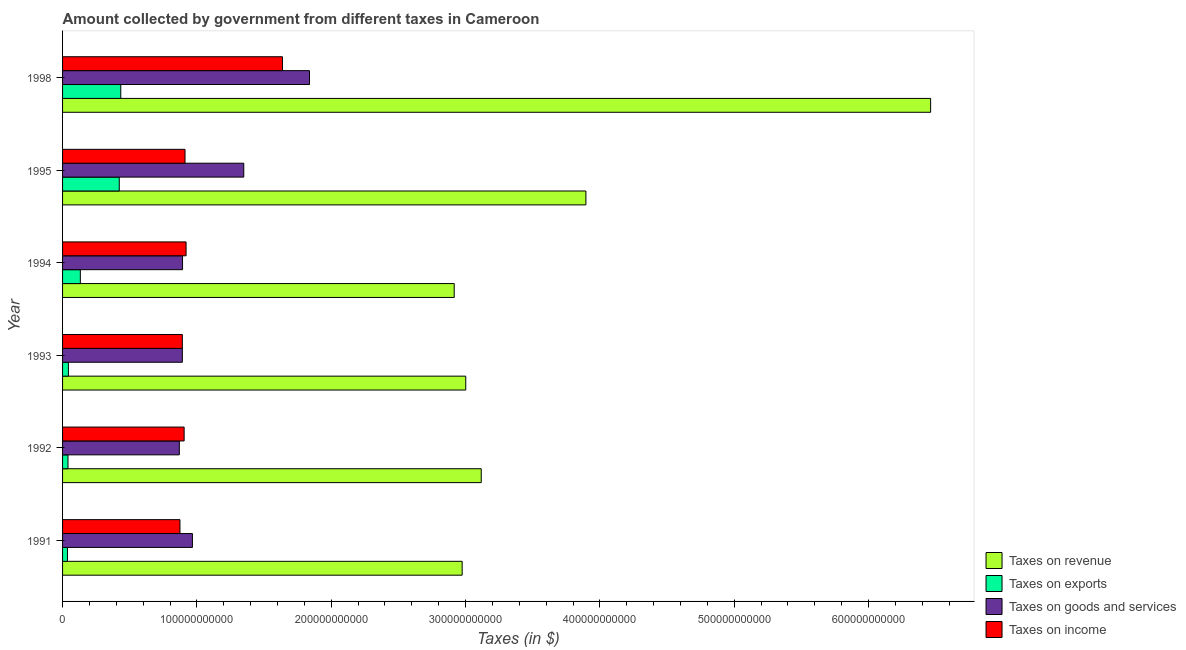How many different coloured bars are there?
Provide a short and direct response. 4. How many bars are there on the 2nd tick from the top?
Ensure brevity in your answer.  4. How many bars are there on the 6th tick from the bottom?
Offer a very short reply. 4. What is the label of the 3rd group of bars from the top?
Your answer should be compact. 1994. In how many cases, is the number of bars for a given year not equal to the number of legend labels?
Keep it short and to the point. 0. What is the amount collected as tax on exports in 1995?
Make the answer very short. 4.22e+1. Across all years, what is the maximum amount collected as tax on exports?
Your response must be concise. 4.33e+1. Across all years, what is the minimum amount collected as tax on exports?
Give a very brief answer. 3.64e+09. In which year was the amount collected as tax on exports maximum?
Provide a succinct answer. 1998. What is the total amount collected as tax on income in the graph?
Make the answer very short. 6.14e+11. What is the difference between the amount collected as tax on goods in 1993 and that in 1995?
Provide a short and direct response. -4.57e+1. What is the difference between the amount collected as tax on goods in 1995 and the amount collected as tax on income in 1992?
Your answer should be compact. 4.44e+1. What is the average amount collected as tax on goods per year?
Keep it short and to the point. 1.13e+11. In the year 1991, what is the difference between the amount collected as tax on revenue and amount collected as tax on income?
Your response must be concise. 2.10e+11. What is the ratio of the amount collected as tax on exports in 1992 to that in 1995?
Give a very brief answer. 0.1. Is the difference between the amount collected as tax on revenue in 1993 and 1998 greater than the difference between the amount collected as tax on income in 1993 and 1998?
Provide a short and direct response. No. What is the difference between the highest and the second highest amount collected as tax on revenue?
Ensure brevity in your answer.  2.57e+11. What is the difference between the highest and the lowest amount collected as tax on goods?
Provide a succinct answer. 9.69e+1. Is the sum of the amount collected as tax on revenue in 1991 and 1998 greater than the maximum amount collected as tax on exports across all years?
Ensure brevity in your answer.  Yes. What does the 2nd bar from the top in 1995 represents?
Provide a short and direct response. Taxes on goods and services. What does the 4th bar from the bottom in 1993 represents?
Keep it short and to the point. Taxes on income. Is it the case that in every year, the sum of the amount collected as tax on revenue and amount collected as tax on exports is greater than the amount collected as tax on goods?
Give a very brief answer. Yes. What is the difference between two consecutive major ticks on the X-axis?
Give a very brief answer. 1.00e+11. Does the graph contain any zero values?
Offer a very short reply. No. How many legend labels are there?
Your answer should be very brief. 4. How are the legend labels stacked?
Provide a succinct answer. Vertical. What is the title of the graph?
Provide a succinct answer. Amount collected by government from different taxes in Cameroon. Does "Social Protection" appear as one of the legend labels in the graph?
Your response must be concise. No. What is the label or title of the X-axis?
Keep it short and to the point. Taxes (in $). What is the Taxes (in $) of Taxes on revenue in 1991?
Give a very brief answer. 2.97e+11. What is the Taxes (in $) in Taxes on exports in 1991?
Ensure brevity in your answer.  3.64e+09. What is the Taxes (in $) in Taxes on goods and services in 1991?
Offer a very short reply. 9.67e+1. What is the Taxes (in $) of Taxes on income in 1991?
Your answer should be compact. 8.74e+1. What is the Taxes (in $) of Taxes on revenue in 1992?
Make the answer very short. 3.12e+11. What is the Taxes (in $) of Taxes on exports in 1992?
Provide a short and direct response. 4.03e+09. What is the Taxes (in $) in Taxes on goods and services in 1992?
Provide a short and direct response. 8.69e+1. What is the Taxes (in $) of Taxes on income in 1992?
Make the answer very short. 9.05e+1. What is the Taxes (in $) of Taxes on revenue in 1993?
Provide a short and direct response. 3.00e+11. What is the Taxes (in $) of Taxes on exports in 1993?
Provide a short and direct response. 4.35e+09. What is the Taxes (in $) in Taxes on goods and services in 1993?
Keep it short and to the point. 8.92e+1. What is the Taxes (in $) in Taxes on income in 1993?
Your answer should be very brief. 8.92e+1. What is the Taxes (in $) in Taxes on revenue in 1994?
Provide a short and direct response. 2.92e+11. What is the Taxes (in $) of Taxes on exports in 1994?
Make the answer very short. 1.32e+1. What is the Taxes (in $) in Taxes on goods and services in 1994?
Your response must be concise. 8.93e+1. What is the Taxes (in $) of Taxes on income in 1994?
Keep it short and to the point. 9.19e+1. What is the Taxes (in $) in Taxes on revenue in 1995?
Provide a short and direct response. 3.90e+11. What is the Taxes (in $) in Taxes on exports in 1995?
Offer a terse response. 4.22e+1. What is the Taxes (in $) in Taxes on goods and services in 1995?
Your response must be concise. 1.35e+11. What is the Taxes (in $) of Taxes on income in 1995?
Your answer should be compact. 9.12e+1. What is the Taxes (in $) in Taxes on revenue in 1998?
Ensure brevity in your answer.  6.46e+11. What is the Taxes (in $) in Taxes on exports in 1998?
Offer a very short reply. 4.33e+1. What is the Taxes (in $) in Taxes on goods and services in 1998?
Give a very brief answer. 1.84e+11. What is the Taxes (in $) in Taxes on income in 1998?
Provide a succinct answer. 1.64e+11. Across all years, what is the maximum Taxes (in $) in Taxes on revenue?
Provide a succinct answer. 6.46e+11. Across all years, what is the maximum Taxes (in $) of Taxes on exports?
Offer a terse response. 4.33e+1. Across all years, what is the maximum Taxes (in $) of Taxes on goods and services?
Ensure brevity in your answer.  1.84e+11. Across all years, what is the maximum Taxes (in $) in Taxes on income?
Provide a succinct answer. 1.64e+11. Across all years, what is the minimum Taxes (in $) in Taxes on revenue?
Offer a terse response. 2.92e+11. Across all years, what is the minimum Taxes (in $) of Taxes on exports?
Provide a succinct answer. 3.64e+09. Across all years, what is the minimum Taxes (in $) in Taxes on goods and services?
Keep it short and to the point. 8.69e+1. Across all years, what is the minimum Taxes (in $) in Taxes on income?
Your answer should be compact. 8.74e+1. What is the total Taxes (in $) in Taxes on revenue in the graph?
Your answer should be very brief. 2.24e+12. What is the total Taxes (in $) of Taxes on exports in the graph?
Give a very brief answer. 1.11e+11. What is the total Taxes (in $) of Taxes on goods and services in the graph?
Give a very brief answer. 6.81e+11. What is the total Taxes (in $) of Taxes on income in the graph?
Your answer should be very brief. 6.14e+11. What is the difference between the Taxes (in $) in Taxes on revenue in 1991 and that in 1992?
Provide a short and direct response. -1.42e+1. What is the difference between the Taxes (in $) in Taxes on exports in 1991 and that in 1992?
Give a very brief answer. -3.90e+08. What is the difference between the Taxes (in $) in Taxes on goods and services in 1991 and that in 1992?
Give a very brief answer. 9.74e+09. What is the difference between the Taxes (in $) in Taxes on income in 1991 and that in 1992?
Keep it short and to the point. -3.12e+09. What is the difference between the Taxes (in $) in Taxes on revenue in 1991 and that in 1993?
Provide a short and direct response. -2.68e+09. What is the difference between the Taxes (in $) of Taxes on exports in 1991 and that in 1993?
Your answer should be very brief. -7.10e+08. What is the difference between the Taxes (in $) of Taxes on goods and services in 1991 and that in 1993?
Provide a succinct answer. 7.50e+09. What is the difference between the Taxes (in $) in Taxes on income in 1991 and that in 1993?
Keep it short and to the point. -1.77e+09. What is the difference between the Taxes (in $) of Taxes on revenue in 1991 and that in 1994?
Provide a succinct answer. 5.91e+09. What is the difference between the Taxes (in $) in Taxes on exports in 1991 and that in 1994?
Ensure brevity in your answer.  -9.59e+09. What is the difference between the Taxes (in $) in Taxes on goods and services in 1991 and that in 1994?
Your answer should be compact. 7.35e+09. What is the difference between the Taxes (in $) in Taxes on income in 1991 and that in 1994?
Your response must be concise. -4.56e+09. What is the difference between the Taxes (in $) in Taxes on revenue in 1991 and that in 1995?
Your answer should be very brief. -9.21e+1. What is the difference between the Taxes (in $) in Taxes on exports in 1991 and that in 1995?
Your answer should be compact. -3.86e+1. What is the difference between the Taxes (in $) in Taxes on goods and services in 1991 and that in 1995?
Keep it short and to the point. -3.82e+1. What is the difference between the Taxes (in $) in Taxes on income in 1991 and that in 1995?
Offer a terse response. -3.77e+09. What is the difference between the Taxes (in $) of Taxes on revenue in 1991 and that in 1998?
Your response must be concise. -3.49e+11. What is the difference between the Taxes (in $) of Taxes on exports in 1991 and that in 1998?
Your response must be concise. -3.97e+1. What is the difference between the Taxes (in $) in Taxes on goods and services in 1991 and that in 1998?
Your answer should be compact. -8.72e+1. What is the difference between the Taxes (in $) in Taxes on income in 1991 and that in 1998?
Provide a short and direct response. -7.63e+1. What is the difference between the Taxes (in $) in Taxes on revenue in 1992 and that in 1993?
Make the answer very short. 1.15e+1. What is the difference between the Taxes (in $) of Taxes on exports in 1992 and that in 1993?
Make the answer very short. -3.20e+08. What is the difference between the Taxes (in $) of Taxes on goods and services in 1992 and that in 1993?
Keep it short and to the point. -2.24e+09. What is the difference between the Taxes (in $) of Taxes on income in 1992 and that in 1993?
Offer a terse response. 1.35e+09. What is the difference between the Taxes (in $) of Taxes on revenue in 1992 and that in 1994?
Your answer should be compact. 2.01e+1. What is the difference between the Taxes (in $) in Taxes on exports in 1992 and that in 1994?
Offer a very short reply. -9.20e+09. What is the difference between the Taxes (in $) in Taxes on goods and services in 1992 and that in 1994?
Ensure brevity in your answer.  -2.39e+09. What is the difference between the Taxes (in $) of Taxes on income in 1992 and that in 1994?
Make the answer very short. -1.44e+09. What is the difference between the Taxes (in $) of Taxes on revenue in 1992 and that in 1995?
Provide a succinct answer. -7.79e+1. What is the difference between the Taxes (in $) in Taxes on exports in 1992 and that in 1995?
Your answer should be compact. -3.82e+1. What is the difference between the Taxes (in $) in Taxes on goods and services in 1992 and that in 1995?
Ensure brevity in your answer.  -4.80e+1. What is the difference between the Taxes (in $) in Taxes on income in 1992 and that in 1995?
Offer a terse response. -6.50e+08. What is the difference between the Taxes (in $) in Taxes on revenue in 1992 and that in 1998?
Provide a succinct answer. -3.35e+11. What is the difference between the Taxes (in $) of Taxes on exports in 1992 and that in 1998?
Make the answer very short. -3.93e+1. What is the difference between the Taxes (in $) of Taxes on goods and services in 1992 and that in 1998?
Your answer should be compact. -9.69e+1. What is the difference between the Taxes (in $) of Taxes on income in 1992 and that in 1998?
Your answer should be compact. -7.32e+1. What is the difference between the Taxes (in $) of Taxes on revenue in 1993 and that in 1994?
Provide a succinct answer. 8.59e+09. What is the difference between the Taxes (in $) in Taxes on exports in 1993 and that in 1994?
Offer a very short reply. -8.88e+09. What is the difference between the Taxes (in $) in Taxes on goods and services in 1993 and that in 1994?
Your answer should be very brief. -1.50e+08. What is the difference between the Taxes (in $) in Taxes on income in 1993 and that in 1994?
Keep it short and to the point. -2.79e+09. What is the difference between the Taxes (in $) of Taxes on revenue in 1993 and that in 1995?
Provide a succinct answer. -8.94e+1. What is the difference between the Taxes (in $) of Taxes on exports in 1993 and that in 1995?
Your response must be concise. -3.79e+1. What is the difference between the Taxes (in $) in Taxes on goods and services in 1993 and that in 1995?
Provide a short and direct response. -4.57e+1. What is the difference between the Taxes (in $) in Taxes on income in 1993 and that in 1995?
Offer a very short reply. -2.00e+09. What is the difference between the Taxes (in $) of Taxes on revenue in 1993 and that in 1998?
Ensure brevity in your answer.  -3.46e+11. What is the difference between the Taxes (in $) of Taxes on exports in 1993 and that in 1998?
Provide a succinct answer. -3.90e+1. What is the difference between the Taxes (in $) in Taxes on goods and services in 1993 and that in 1998?
Keep it short and to the point. -9.47e+1. What is the difference between the Taxes (in $) in Taxes on income in 1993 and that in 1998?
Provide a succinct answer. -7.45e+1. What is the difference between the Taxes (in $) of Taxes on revenue in 1994 and that in 1995?
Make the answer very short. -9.80e+1. What is the difference between the Taxes (in $) in Taxes on exports in 1994 and that in 1995?
Your answer should be very brief. -2.90e+1. What is the difference between the Taxes (in $) of Taxes on goods and services in 1994 and that in 1995?
Provide a short and direct response. -4.56e+1. What is the difference between the Taxes (in $) of Taxes on income in 1994 and that in 1995?
Offer a terse response. 7.90e+08. What is the difference between the Taxes (in $) of Taxes on revenue in 1994 and that in 1998?
Provide a short and direct response. -3.55e+11. What is the difference between the Taxes (in $) of Taxes on exports in 1994 and that in 1998?
Your answer should be compact. -3.01e+1. What is the difference between the Taxes (in $) of Taxes on goods and services in 1994 and that in 1998?
Your answer should be compact. -9.45e+1. What is the difference between the Taxes (in $) in Taxes on income in 1994 and that in 1998?
Your response must be concise. -7.18e+1. What is the difference between the Taxes (in $) in Taxes on revenue in 1995 and that in 1998?
Keep it short and to the point. -2.57e+11. What is the difference between the Taxes (in $) in Taxes on exports in 1995 and that in 1998?
Offer a terse response. -1.11e+09. What is the difference between the Taxes (in $) in Taxes on goods and services in 1995 and that in 1998?
Offer a terse response. -4.89e+1. What is the difference between the Taxes (in $) of Taxes on income in 1995 and that in 1998?
Your answer should be very brief. -7.25e+1. What is the difference between the Taxes (in $) in Taxes on revenue in 1991 and the Taxes (in $) in Taxes on exports in 1992?
Give a very brief answer. 2.93e+11. What is the difference between the Taxes (in $) of Taxes on revenue in 1991 and the Taxes (in $) of Taxes on goods and services in 1992?
Make the answer very short. 2.11e+11. What is the difference between the Taxes (in $) of Taxes on revenue in 1991 and the Taxes (in $) of Taxes on income in 1992?
Offer a very short reply. 2.07e+11. What is the difference between the Taxes (in $) in Taxes on exports in 1991 and the Taxes (in $) in Taxes on goods and services in 1992?
Offer a terse response. -8.33e+1. What is the difference between the Taxes (in $) in Taxes on exports in 1991 and the Taxes (in $) in Taxes on income in 1992?
Make the answer very short. -8.69e+1. What is the difference between the Taxes (in $) of Taxes on goods and services in 1991 and the Taxes (in $) of Taxes on income in 1992?
Your answer should be very brief. 6.16e+09. What is the difference between the Taxes (in $) of Taxes on revenue in 1991 and the Taxes (in $) of Taxes on exports in 1993?
Provide a short and direct response. 2.93e+11. What is the difference between the Taxes (in $) of Taxes on revenue in 1991 and the Taxes (in $) of Taxes on goods and services in 1993?
Offer a terse response. 2.08e+11. What is the difference between the Taxes (in $) in Taxes on revenue in 1991 and the Taxes (in $) in Taxes on income in 1993?
Provide a succinct answer. 2.08e+11. What is the difference between the Taxes (in $) of Taxes on exports in 1991 and the Taxes (in $) of Taxes on goods and services in 1993?
Make the answer very short. -8.55e+1. What is the difference between the Taxes (in $) in Taxes on exports in 1991 and the Taxes (in $) in Taxes on income in 1993?
Your response must be concise. -8.55e+1. What is the difference between the Taxes (in $) of Taxes on goods and services in 1991 and the Taxes (in $) of Taxes on income in 1993?
Keep it short and to the point. 7.51e+09. What is the difference between the Taxes (in $) of Taxes on revenue in 1991 and the Taxes (in $) of Taxes on exports in 1994?
Provide a succinct answer. 2.84e+11. What is the difference between the Taxes (in $) of Taxes on revenue in 1991 and the Taxes (in $) of Taxes on goods and services in 1994?
Ensure brevity in your answer.  2.08e+11. What is the difference between the Taxes (in $) in Taxes on revenue in 1991 and the Taxes (in $) in Taxes on income in 1994?
Make the answer very short. 2.06e+11. What is the difference between the Taxes (in $) in Taxes on exports in 1991 and the Taxes (in $) in Taxes on goods and services in 1994?
Provide a succinct answer. -8.57e+1. What is the difference between the Taxes (in $) of Taxes on exports in 1991 and the Taxes (in $) of Taxes on income in 1994?
Offer a terse response. -8.83e+1. What is the difference between the Taxes (in $) in Taxes on goods and services in 1991 and the Taxes (in $) in Taxes on income in 1994?
Ensure brevity in your answer.  4.72e+09. What is the difference between the Taxes (in $) of Taxes on revenue in 1991 and the Taxes (in $) of Taxes on exports in 1995?
Ensure brevity in your answer.  2.55e+11. What is the difference between the Taxes (in $) of Taxes on revenue in 1991 and the Taxes (in $) of Taxes on goods and services in 1995?
Your answer should be very brief. 1.63e+11. What is the difference between the Taxes (in $) in Taxes on revenue in 1991 and the Taxes (in $) in Taxes on income in 1995?
Your response must be concise. 2.06e+11. What is the difference between the Taxes (in $) of Taxes on exports in 1991 and the Taxes (in $) of Taxes on goods and services in 1995?
Ensure brevity in your answer.  -1.31e+11. What is the difference between the Taxes (in $) of Taxes on exports in 1991 and the Taxes (in $) of Taxes on income in 1995?
Your response must be concise. -8.75e+1. What is the difference between the Taxes (in $) of Taxes on goods and services in 1991 and the Taxes (in $) of Taxes on income in 1995?
Your answer should be very brief. 5.51e+09. What is the difference between the Taxes (in $) of Taxes on revenue in 1991 and the Taxes (in $) of Taxes on exports in 1998?
Ensure brevity in your answer.  2.54e+11. What is the difference between the Taxes (in $) of Taxes on revenue in 1991 and the Taxes (in $) of Taxes on goods and services in 1998?
Give a very brief answer. 1.14e+11. What is the difference between the Taxes (in $) in Taxes on revenue in 1991 and the Taxes (in $) in Taxes on income in 1998?
Offer a very short reply. 1.34e+11. What is the difference between the Taxes (in $) of Taxes on exports in 1991 and the Taxes (in $) of Taxes on goods and services in 1998?
Your answer should be very brief. -1.80e+11. What is the difference between the Taxes (in $) of Taxes on exports in 1991 and the Taxes (in $) of Taxes on income in 1998?
Your response must be concise. -1.60e+11. What is the difference between the Taxes (in $) of Taxes on goods and services in 1991 and the Taxes (in $) of Taxes on income in 1998?
Keep it short and to the point. -6.70e+1. What is the difference between the Taxes (in $) of Taxes on revenue in 1992 and the Taxes (in $) of Taxes on exports in 1993?
Provide a short and direct response. 3.07e+11. What is the difference between the Taxes (in $) of Taxes on revenue in 1992 and the Taxes (in $) of Taxes on goods and services in 1993?
Your answer should be compact. 2.22e+11. What is the difference between the Taxes (in $) in Taxes on revenue in 1992 and the Taxes (in $) in Taxes on income in 1993?
Provide a succinct answer. 2.23e+11. What is the difference between the Taxes (in $) in Taxes on exports in 1992 and the Taxes (in $) in Taxes on goods and services in 1993?
Make the answer very short. -8.51e+1. What is the difference between the Taxes (in $) of Taxes on exports in 1992 and the Taxes (in $) of Taxes on income in 1993?
Ensure brevity in your answer.  -8.51e+1. What is the difference between the Taxes (in $) in Taxes on goods and services in 1992 and the Taxes (in $) in Taxes on income in 1993?
Ensure brevity in your answer.  -2.23e+09. What is the difference between the Taxes (in $) of Taxes on revenue in 1992 and the Taxes (in $) of Taxes on exports in 1994?
Offer a very short reply. 2.98e+11. What is the difference between the Taxes (in $) of Taxes on revenue in 1992 and the Taxes (in $) of Taxes on goods and services in 1994?
Keep it short and to the point. 2.22e+11. What is the difference between the Taxes (in $) in Taxes on revenue in 1992 and the Taxes (in $) in Taxes on income in 1994?
Keep it short and to the point. 2.20e+11. What is the difference between the Taxes (in $) in Taxes on exports in 1992 and the Taxes (in $) in Taxes on goods and services in 1994?
Offer a terse response. -8.53e+1. What is the difference between the Taxes (in $) of Taxes on exports in 1992 and the Taxes (in $) of Taxes on income in 1994?
Keep it short and to the point. -8.79e+1. What is the difference between the Taxes (in $) of Taxes on goods and services in 1992 and the Taxes (in $) of Taxes on income in 1994?
Ensure brevity in your answer.  -5.02e+09. What is the difference between the Taxes (in $) in Taxes on revenue in 1992 and the Taxes (in $) in Taxes on exports in 1995?
Provide a short and direct response. 2.69e+11. What is the difference between the Taxes (in $) of Taxes on revenue in 1992 and the Taxes (in $) of Taxes on goods and services in 1995?
Keep it short and to the point. 1.77e+11. What is the difference between the Taxes (in $) of Taxes on revenue in 1992 and the Taxes (in $) of Taxes on income in 1995?
Give a very brief answer. 2.21e+11. What is the difference between the Taxes (in $) in Taxes on exports in 1992 and the Taxes (in $) in Taxes on goods and services in 1995?
Offer a very short reply. -1.31e+11. What is the difference between the Taxes (in $) in Taxes on exports in 1992 and the Taxes (in $) in Taxes on income in 1995?
Provide a short and direct response. -8.71e+1. What is the difference between the Taxes (in $) of Taxes on goods and services in 1992 and the Taxes (in $) of Taxes on income in 1995?
Your response must be concise. -4.23e+09. What is the difference between the Taxes (in $) of Taxes on revenue in 1992 and the Taxes (in $) of Taxes on exports in 1998?
Your response must be concise. 2.68e+11. What is the difference between the Taxes (in $) of Taxes on revenue in 1992 and the Taxes (in $) of Taxes on goods and services in 1998?
Offer a very short reply. 1.28e+11. What is the difference between the Taxes (in $) of Taxes on revenue in 1992 and the Taxes (in $) of Taxes on income in 1998?
Keep it short and to the point. 1.48e+11. What is the difference between the Taxes (in $) in Taxes on exports in 1992 and the Taxes (in $) in Taxes on goods and services in 1998?
Your answer should be very brief. -1.80e+11. What is the difference between the Taxes (in $) in Taxes on exports in 1992 and the Taxes (in $) in Taxes on income in 1998?
Ensure brevity in your answer.  -1.60e+11. What is the difference between the Taxes (in $) of Taxes on goods and services in 1992 and the Taxes (in $) of Taxes on income in 1998?
Offer a very short reply. -7.68e+1. What is the difference between the Taxes (in $) in Taxes on revenue in 1993 and the Taxes (in $) in Taxes on exports in 1994?
Keep it short and to the point. 2.87e+11. What is the difference between the Taxes (in $) in Taxes on revenue in 1993 and the Taxes (in $) in Taxes on goods and services in 1994?
Your response must be concise. 2.11e+11. What is the difference between the Taxes (in $) of Taxes on revenue in 1993 and the Taxes (in $) of Taxes on income in 1994?
Offer a very short reply. 2.08e+11. What is the difference between the Taxes (in $) of Taxes on exports in 1993 and the Taxes (in $) of Taxes on goods and services in 1994?
Give a very brief answer. -8.50e+1. What is the difference between the Taxes (in $) in Taxes on exports in 1993 and the Taxes (in $) in Taxes on income in 1994?
Your response must be concise. -8.76e+1. What is the difference between the Taxes (in $) of Taxes on goods and services in 1993 and the Taxes (in $) of Taxes on income in 1994?
Your answer should be compact. -2.78e+09. What is the difference between the Taxes (in $) of Taxes on revenue in 1993 and the Taxes (in $) of Taxes on exports in 1995?
Offer a terse response. 2.58e+11. What is the difference between the Taxes (in $) in Taxes on revenue in 1993 and the Taxes (in $) in Taxes on goods and services in 1995?
Ensure brevity in your answer.  1.65e+11. What is the difference between the Taxes (in $) in Taxes on revenue in 1993 and the Taxes (in $) in Taxes on income in 1995?
Your answer should be very brief. 2.09e+11. What is the difference between the Taxes (in $) of Taxes on exports in 1993 and the Taxes (in $) of Taxes on goods and services in 1995?
Your answer should be very brief. -1.31e+11. What is the difference between the Taxes (in $) of Taxes on exports in 1993 and the Taxes (in $) of Taxes on income in 1995?
Provide a short and direct response. -8.68e+1. What is the difference between the Taxes (in $) of Taxes on goods and services in 1993 and the Taxes (in $) of Taxes on income in 1995?
Ensure brevity in your answer.  -1.99e+09. What is the difference between the Taxes (in $) of Taxes on revenue in 1993 and the Taxes (in $) of Taxes on exports in 1998?
Give a very brief answer. 2.57e+11. What is the difference between the Taxes (in $) in Taxes on revenue in 1993 and the Taxes (in $) in Taxes on goods and services in 1998?
Keep it short and to the point. 1.16e+11. What is the difference between the Taxes (in $) in Taxes on revenue in 1993 and the Taxes (in $) in Taxes on income in 1998?
Ensure brevity in your answer.  1.36e+11. What is the difference between the Taxes (in $) of Taxes on exports in 1993 and the Taxes (in $) of Taxes on goods and services in 1998?
Keep it short and to the point. -1.79e+11. What is the difference between the Taxes (in $) in Taxes on exports in 1993 and the Taxes (in $) in Taxes on income in 1998?
Your answer should be compact. -1.59e+11. What is the difference between the Taxes (in $) of Taxes on goods and services in 1993 and the Taxes (in $) of Taxes on income in 1998?
Your response must be concise. -7.45e+1. What is the difference between the Taxes (in $) of Taxes on revenue in 1994 and the Taxes (in $) of Taxes on exports in 1995?
Offer a terse response. 2.49e+11. What is the difference between the Taxes (in $) in Taxes on revenue in 1994 and the Taxes (in $) in Taxes on goods and services in 1995?
Give a very brief answer. 1.57e+11. What is the difference between the Taxes (in $) of Taxes on revenue in 1994 and the Taxes (in $) of Taxes on income in 1995?
Make the answer very short. 2.00e+11. What is the difference between the Taxes (in $) of Taxes on exports in 1994 and the Taxes (in $) of Taxes on goods and services in 1995?
Give a very brief answer. -1.22e+11. What is the difference between the Taxes (in $) of Taxes on exports in 1994 and the Taxes (in $) of Taxes on income in 1995?
Provide a short and direct response. -7.79e+1. What is the difference between the Taxes (in $) in Taxes on goods and services in 1994 and the Taxes (in $) in Taxes on income in 1995?
Offer a very short reply. -1.84e+09. What is the difference between the Taxes (in $) in Taxes on revenue in 1994 and the Taxes (in $) in Taxes on exports in 1998?
Your answer should be very brief. 2.48e+11. What is the difference between the Taxes (in $) in Taxes on revenue in 1994 and the Taxes (in $) in Taxes on goods and services in 1998?
Your answer should be very brief. 1.08e+11. What is the difference between the Taxes (in $) in Taxes on revenue in 1994 and the Taxes (in $) in Taxes on income in 1998?
Your answer should be very brief. 1.28e+11. What is the difference between the Taxes (in $) in Taxes on exports in 1994 and the Taxes (in $) in Taxes on goods and services in 1998?
Keep it short and to the point. -1.71e+11. What is the difference between the Taxes (in $) in Taxes on exports in 1994 and the Taxes (in $) in Taxes on income in 1998?
Your answer should be compact. -1.50e+11. What is the difference between the Taxes (in $) of Taxes on goods and services in 1994 and the Taxes (in $) of Taxes on income in 1998?
Provide a succinct answer. -7.44e+1. What is the difference between the Taxes (in $) of Taxes on revenue in 1995 and the Taxes (in $) of Taxes on exports in 1998?
Ensure brevity in your answer.  3.46e+11. What is the difference between the Taxes (in $) in Taxes on revenue in 1995 and the Taxes (in $) in Taxes on goods and services in 1998?
Your answer should be very brief. 2.06e+11. What is the difference between the Taxes (in $) of Taxes on revenue in 1995 and the Taxes (in $) of Taxes on income in 1998?
Your answer should be compact. 2.26e+11. What is the difference between the Taxes (in $) of Taxes on exports in 1995 and the Taxes (in $) of Taxes on goods and services in 1998?
Your answer should be compact. -1.42e+11. What is the difference between the Taxes (in $) of Taxes on exports in 1995 and the Taxes (in $) of Taxes on income in 1998?
Ensure brevity in your answer.  -1.21e+11. What is the difference between the Taxes (in $) of Taxes on goods and services in 1995 and the Taxes (in $) of Taxes on income in 1998?
Make the answer very short. -2.88e+1. What is the average Taxes (in $) in Taxes on revenue per year?
Offer a very short reply. 3.73e+11. What is the average Taxes (in $) of Taxes on exports per year?
Your response must be concise. 1.85e+1. What is the average Taxes (in $) in Taxes on goods and services per year?
Ensure brevity in your answer.  1.13e+11. What is the average Taxes (in $) in Taxes on income per year?
Give a very brief answer. 1.02e+11. In the year 1991, what is the difference between the Taxes (in $) of Taxes on revenue and Taxes (in $) of Taxes on exports?
Your answer should be compact. 2.94e+11. In the year 1991, what is the difference between the Taxes (in $) of Taxes on revenue and Taxes (in $) of Taxes on goods and services?
Offer a terse response. 2.01e+11. In the year 1991, what is the difference between the Taxes (in $) in Taxes on revenue and Taxes (in $) in Taxes on income?
Keep it short and to the point. 2.10e+11. In the year 1991, what is the difference between the Taxes (in $) in Taxes on exports and Taxes (in $) in Taxes on goods and services?
Offer a very short reply. -9.30e+1. In the year 1991, what is the difference between the Taxes (in $) of Taxes on exports and Taxes (in $) of Taxes on income?
Offer a terse response. -8.37e+1. In the year 1991, what is the difference between the Taxes (in $) of Taxes on goods and services and Taxes (in $) of Taxes on income?
Provide a succinct answer. 9.28e+09. In the year 1992, what is the difference between the Taxes (in $) in Taxes on revenue and Taxes (in $) in Taxes on exports?
Offer a terse response. 3.08e+11. In the year 1992, what is the difference between the Taxes (in $) of Taxes on revenue and Taxes (in $) of Taxes on goods and services?
Provide a short and direct response. 2.25e+11. In the year 1992, what is the difference between the Taxes (in $) in Taxes on revenue and Taxes (in $) in Taxes on income?
Offer a very short reply. 2.21e+11. In the year 1992, what is the difference between the Taxes (in $) of Taxes on exports and Taxes (in $) of Taxes on goods and services?
Give a very brief answer. -8.29e+1. In the year 1992, what is the difference between the Taxes (in $) of Taxes on exports and Taxes (in $) of Taxes on income?
Ensure brevity in your answer.  -8.65e+1. In the year 1992, what is the difference between the Taxes (in $) in Taxes on goods and services and Taxes (in $) in Taxes on income?
Your answer should be very brief. -3.58e+09. In the year 1993, what is the difference between the Taxes (in $) in Taxes on revenue and Taxes (in $) in Taxes on exports?
Give a very brief answer. 2.96e+11. In the year 1993, what is the difference between the Taxes (in $) of Taxes on revenue and Taxes (in $) of Taxes on goods and services?
Provide a short and direct response. 2.11e+11. In the year 1993, what is the difference between the Taxes (in $) of Taxes on revenue and Taxes (in $) of Taxes on income?
Make the answer very short. 2.11e+11. In the year 1993, what is the difference between the Taxes (in $) of Taxes on exports and Taxes (in $) of Taxes on goods and services?
Offer a terse response. -8.48e+1. In the year 1993, what is the difference between the Taxes (in $) in Taxes on exports and Taxes (in $) in Taxes on income?
Provide a short and direct response. -8.48e+1. In the year 1993, what is the difference between the Taxes (in $) in Taxes on goods and services and Taxes (in $) in Taxes on income?
Ensure brevity in your answer.  1.00e+07. In the year 1994, what is the difference between the Taxes (in $) in Taxes on revenue and Taxes (in $) in Taxes on exports?
Your response must be concise. 2.78e+11. In the year 1994, what is the difference between the Taxes (in $) in Taxes on revenue and Taxes (in $) in Taxes on goods and services?
Ensure brevity in your answer.  2.02e+11. In the year 1994, what is the difference between the Taxes (in $) in Taxes on revenue and Taxes (in $) in Taxes on income?
Make the answer very short. 2.00e+11. In the year 1994, what is the difference between the Taxes (in $) of Taxes on exports and Taxes (in $) of Taxes on goods and services?
Make the answer very short. -7.61e+1. In the year 1994, what is the difference between the Taxes (in $) of Taxes on exports and Taxes (in $) of Taxes on income?
Provide a short and direct response. -7.87e+1. In the year 1994, what is the difference between the Taxes (in $) of Taxes on goods and services and Taxes (in $) of Taxes on income?
Your response must be concise. -2.63e+09. In the year 1995, what is the difference between the Taxes (in $) in Taxes on revenue and Taxes (in $) in Taxes on exports?
Ensure brevity in your answer.  3.47e+11. In the year 1995, what is the difference between the Taxes (in $) of Taxes on revenue and Taxes (in $) of Taxes on goods and services?
Give a very brief answer. 2.55e+11. In the year 1995, what is the difference between the Taxes (in $) of Taxes on revenue and Taxes (in $) of Taxes on income?
Make the answer very short. 2.98e+11. In the year 1995, what is the difference between the Taxes (in $) of Taxes on exports and Taxes (in $) of Taxes on goods and services?
Your answer should be very brief. -9.27e+1. In the year 1995, what is the difference between the Taxes (in $) in Taxes on exports and Taxes (in $) in Taxes on income?
Offer a very short reply. -4.89e+1. In the year 1995, what is the difference between the Taxes (in $) in Taxes on goods and services and Taxes (in $) in Taxes on income?
Provide a short and direct response. 4.37e+1. In the year 1998, what is the difference between the Taxes (in $) in Taxes on revenue and Taxes (in $) in Taxes on exports?
Give a very brief answer. 6.03e+11. In the year 1998, what is the difference between the Taxes (in $) of Taxes on revenue and Taxes (in $) of Taxes on goods and services?
Offer a terse response. 4.62e+11. In the year 1998, what is the difference between the Taxes (in $) of Taxes on revenue and Taxes (in $) of Taxes on income?
Offer a terse response. 4.82e+11. In the year 1998, what is the difference between the Taxes (in $) in Taxes on exports and Taxes (in $) in Taxes on goods and services?
Offer a terse response. -1.40e+11. In the year 1998, what is the difference between the Taxes (in $) of Taxes on exports and Taxes (in $) of Taxes on income?
Your response must be concise. -1.20e+11. In the year 1998, what is the difference between the Taxes (in $) of Taxes on goods and services and Taxes (in $) of Taxes on income?
Provide a succinct answer. 2.01e+1. What is the ratio of the Taxes (in $) in Taxes on revenue in 1991 to that in 1992?
Provide a succinct answer. 0.95. What is the ratio of the Taxes (in $) of Taxes on exports in 1991 to that in 1992?
Make the answer very short. 0.9. What is the ratio of the Taxes (in $) of Taxes on goods and services in 1991 to that in 1992?
Give a very brief answer. 1.11. What is the ratio of the Taxes (in $) in Taxes on income in 1991 to that in 1992?
Keep it short and to the point. 0.97. What is the ratio of the Taxes (in $) in Taxes on exports in 1991 to that in 1993?
Keep it short and to the point. 0.84. What is the ratio of the Taxes (in $) of Taxes on goods and services in 1991 to that in 1993?
Provide a short and direct response. 1.08. What is the ratio of the Taxes (in $) in Taxes on income in 1991 to that in 1993?
Offer a terse response. 0.98. What is the ratio of the Taxes (in $) in Taxes on revenue in 1991 to that in 1994?
Keep it short and to the point. 1.02. What is the ratio of the Taxes (in $) in Taxes on exports in 1991 to that in 1994?
Provide a short and direct response. 0.28. What is the ratio of the Taxes (in $) in Taxes on goods and services in 1991 to that in 1994?
Keep it short and to the point. 1.08. What is the ratio of the Taxes (in $) of Taxes on income in 1991 to that in 1994?
Provide a succinct answer. 0.95. What is the ratio of the Taxes (in $) in Taxes on revenue in 1991 to that in 1995?
Ensure brevity in your answer.  0.76. What is the ratio of the Taxes (in $) of Taxes on exports in 1991 to that in 1995?
Make the answer very short. 0.09. What is the ratio of the Taxes (in $) of Taxes on goods and services in 1991 to that in 1995?
Provide a succinct answer. 0.72. What is the ratio of the Taxes (in $) in Taxes on income in 1991 to that in 1995?
Give a very brief answer. 0.96. What is the ratio of the Taxes (in $) in Taxes on revenue in 1991 to that in 1998?
Your answer should be compact. 0.46. What is the ratio of the Taxes (in $) of Taxes on exports in 1991 to that in 1998?
Make the answer very short. 0.08. What is the ratio of the Taxes (in $) in Taxes on goods and services in 1991 to that in 1998?
Offer a very short reply. 0.53. What is the ratio of the Taxes (in $) of Taxes on income in 1991 to that in 1998?
Keep it short and to the point. 0.53. What is the ratio of the Taxes (in $) of Taxes on revenue in 1992 to that in 1993?
Make the answer very short. 1.04. What is the ratio of the Taxes (in $) in Taxes on exports in 1992 to that in 1993?
Your answer should be compact. 0.93. What is the ratio of the Taxes (in $) in Taxes on goods and services in 1992 to that in 1993?
Your answer should be compact. 0.97. What is the ratio of the Taxes (in $) of Taxes on income in 1992 to that in 1993?
Offer a very short reply. 1.02. What is the ratio of the Taxes (in $) of Taxes on revenue in 1992 to that in 1994?
Offer a very short reply. 1.07. What is the ratio of the Taxes (in $) in Taxes on exports in 1992 to that in 1994?
Provide a short and direct response. 0.3. What is the ratio of the Taxes (in $) in Taxes on goods and services in 1992 to that in 1994?
Provide a succinct answer. 0.97. What is the ratio of the Taxes (in $) in Taxes on income in 1992 to that in 1994?
Provide a short and direct response. 0.98. What is the ratio of the Taxes (in $) of Taxes on exports in 1992 to that in 1995?
Your answer should be compact. 0.1. What is the ratio of the Taxes (in $) in Taxes on goods and services in 1992 to that in 1995?
Provide a succinct answer. 0.64. What is the ratio of the Taxes (in $) in Taxes on income in 1992 to that in 1995?
Your answer should be very brief. 0.99. What is the ratio of the Taxes (in $) in Taxes on revenue in 1992 to that in 1998?
Offer a very short reply. 0.48. What is the ratio of the Taxes (in $) in Taxes on exports in 1992 to that in 1998?
Keep it short and to the point. 0.09. What is the ratio of the Taxes (in $) of Taxes on goods and services in 1992 to that in 1998?
Your answer should be very brief. 0.47. What is the ratio of the Taxes (in $) of Taxes on income in 1992 to that in 1998?
Your answer should be compact. 0.55. What is the ratio of the Taxes (in $) in Taxes on revenue in 1993 to that in 1994?
Your answer should be very brief. 1.03. What is the ratio of the Taxes (in $) of Taxes on exports in 1993 to that in 1994?
Your response must be concise. 0.33. What is the ratio of the Taxes (in $) in Taxes on income in 1993 to that in 1994?
Your answer should be very brief. 0.97. What is the ratio of the Taxes (in $) in Taxes on revenue in 1993 to that in 1995?
Give a very brief answer. 0.77. What is the ratio of the Taxes (in $) in Taxes on exports in 1993 to that in 1995?
Provide a succinct answer. 0.1. What is the ratio of the Taxes (in $) of Taxes on goods and services in 1993 to that in 1995?
Your response must be concise. 0.66. What is the ratio of the Taxes (in $) of Taxes on income in 1993 to that in 1995?
Your answer should be compact. 0.98. What is the ratio of the Taxes (in $) in Taxes on revenue in 1993 to that in 1998?
Provide a succinct answer. 0.46. What is the ratio of the Taxes (in $) of Taxes on exports in 1993 to that in 1998?
Your answer should be compact. 0.1. What is the ratio of the Taxes (in $) of Taxes on goods and services in 1993 to that in 1998?
Your answer should be very brief. 0.48. What is the ratio of the Taxes (in $) in Taxes on income in 1993 to that in 1998?
Give a very brief answer. 0.54. What is the ratio of the Taxes (in $) of Taxes on revenue in 1994 to that in 1995?
Your answer should be compact. 0.75. What is the ratio of the Taxes (in $) of Taxes on exports in 1994 to that in 1995?
Provide a short and direct response. 0.31. What is the ratio of the Taxes (in $) of Taxes on goods and services in 1994 to that in 1995?
Provide a short and direct response. 0.66. What is the ratio of the Taxes (in $) in Taxes on income in 1994 to that in 1995?
Provide a succinct answer. 1.01. What is the ratio of the Taxes (in $) in Taxes on revenue in 1994 to that in 1998?
Offer a terse response. 0.45. What is the ratio of the Taxes (in $) of Taxes on exports in 1994 to that in 1998?
Offer a very short reply. 0.31. What is the ratio of the Taxes (in $) of Taxes on goods and services in 1994 to that in 1998?
Make the answer very short. 0.49. What is the ratio of the Taxes (in $) in Taxes on income in 1994 to that in 1998?
Ensure brevity in your answer.  0.56. What is the ratio of the Taxes (in $) of Taxes on revenue in 1995 to that in 1998?
Offer a terse response. 0.6. What is the ratio of the Taxes (in $) of Taxes on exports in 1995 to that in 1998?
Give a very brief answer. 0.97. What is the ratio of the Taxes (in $) in Taxes on goods and services in 1995 to that in 1998?
Keep it short and to the point. 0.73. What is the ratio of the Taxes (in $) in Taxes on income in 1995 to that in 1998?
Provide a succinct answer. 0.56. What is the difference between the highest and the second highest Taxes (in $) of Taxes on revenue?
Offer a very short reply. 2.57e+11. What is the difference between the highest and the second highest Taxes (in $) of Taxes on exports?
Ensure brevity in your answer.  1.11e+09. What is the difference between the highest and the second highest Taxes (in $) in Taxes on goods and services?
Provide a succinct answer. 4.89e+1. What is the difference between the highest and the second highest Taxes (in $) of Taxes on income?
Your answer should be compact. 7.18e+1. What is the difference between the highest and the lowest Taxes (in $) of Taxes on revenue?
Provide a succinct answer. 3.55e+11. What is the difference between the highest and the lowest Taxes (in $) of Taxes on exports?
Your answer should be compact. 3.97e+1. What is the difference between the highest and the lowest Taxes (in $) of Taxes on goods and services?
Ensure brevity in your answer.  9.69e+1. What is the difference between the highest and the lowest Taxes (in $) in Taxes on income?
Provide a short and direct response. 7.63e+1. 